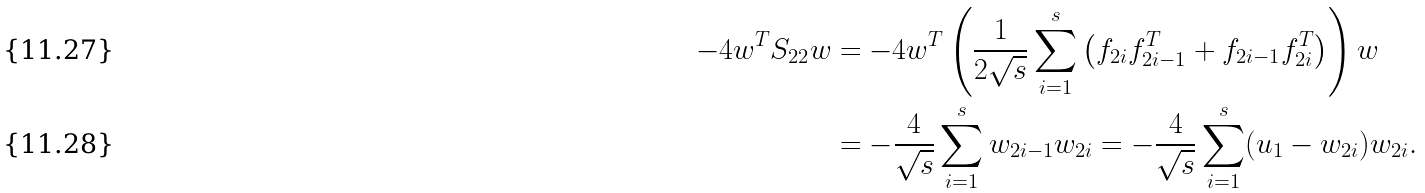Convert formula to latex. <formula><loc_0><loc_0><loc_500><loc_500>- 4 w ^ { T } S _ { 2 2 } w & = - 4 w ^ { T } \left ( \frac { 1 } { 2 \sqrt { s } } \sum _ { i = 1 } ^ { s } \left ( f _ { 2 i } f _ { 2 i - 1 } ^ { T } + f _ { 2 i - 1 } f _ { 2 i } ^ { T } \right ) \right ) w \\ & = - \frac { 4 } { \sqrt { s } } \sum _ { i = 1 } ^ { s } w _ { 2 i - 1 } w _ { 2 i } = - \frac { 4 } { \sqrt { s } } \sum _ { i = 1 } ^ { s } ( u _ { 1 } - w _ { 2 i } ) w _ { 2 i } .</formula> 